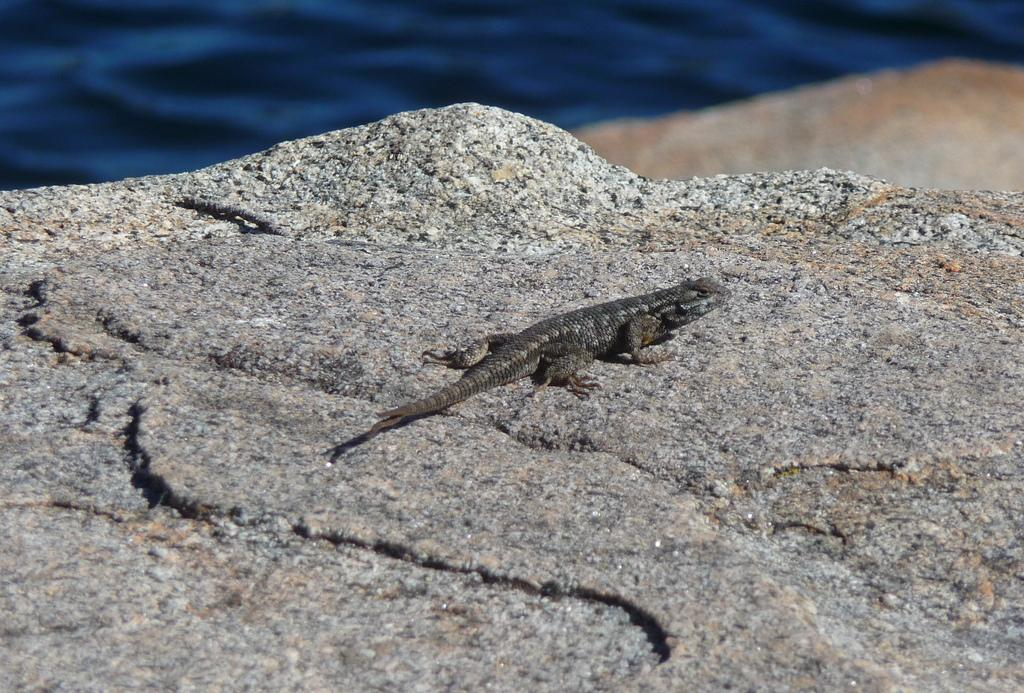What animal is present in the image? There is a lizard in the image. What is the lizard standing on? The lizard is on a stone. Can you describe the background of the image? The background of the image is blurred. Where is the nest of the lizard in the image? There is no nest present in the image; it only features a lizard on a stone. 